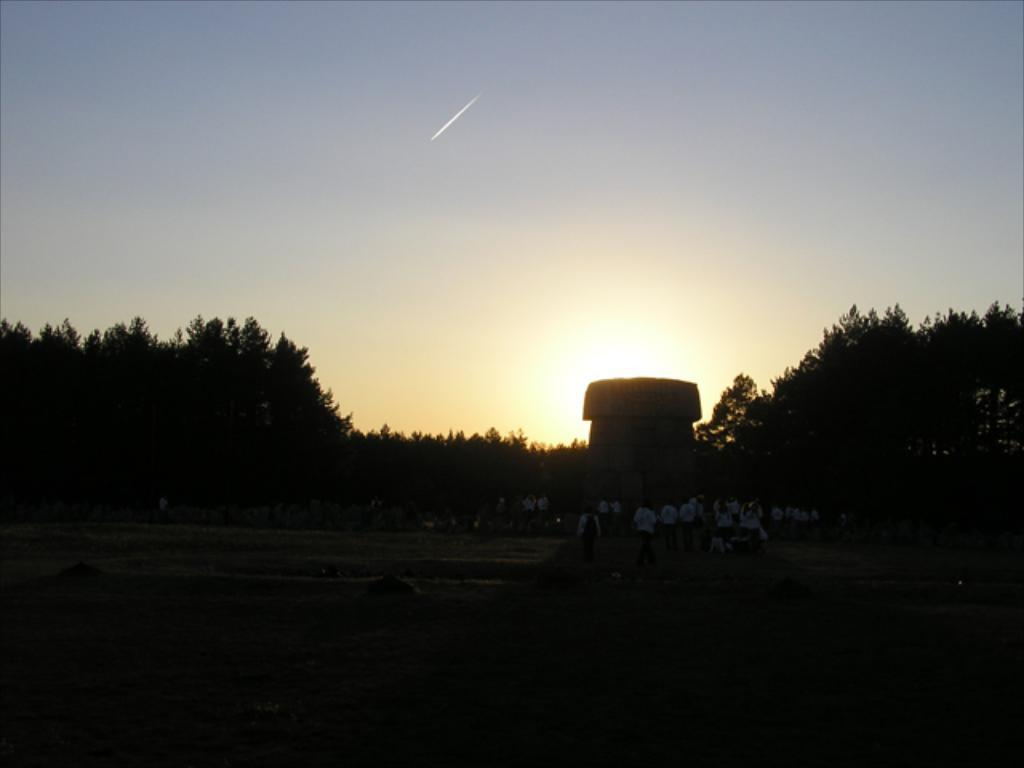Who or what is present in the image? There are people in the image. What structure can be seen in the image? There is a pillar in the image. What can be seen in the distance in the image? There are trees in the background of the image. What type of ball is being used by the people in the image? There is no ball present in the image; the people are not engaged in any ball-related activities. 